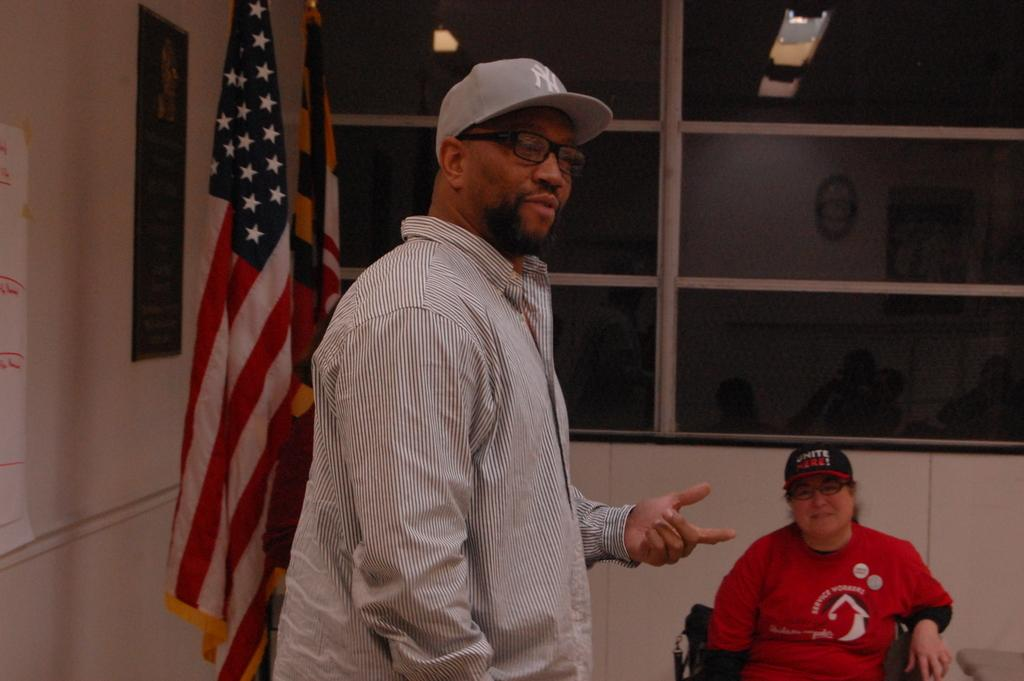How many people are in the image? There are two persons in the image. What else can be seen in the image besides the people? There are flags, windows, a board, and paper attached to the wall in the image. What type of wrench is being used by one of the persons in the image? There is no wrench present in the image. How does the paper attached to the wall increase the level of fear in the image? There is no indication of fear in the image, and the paper attached to the wall does not increase or decrease any level of fear. 